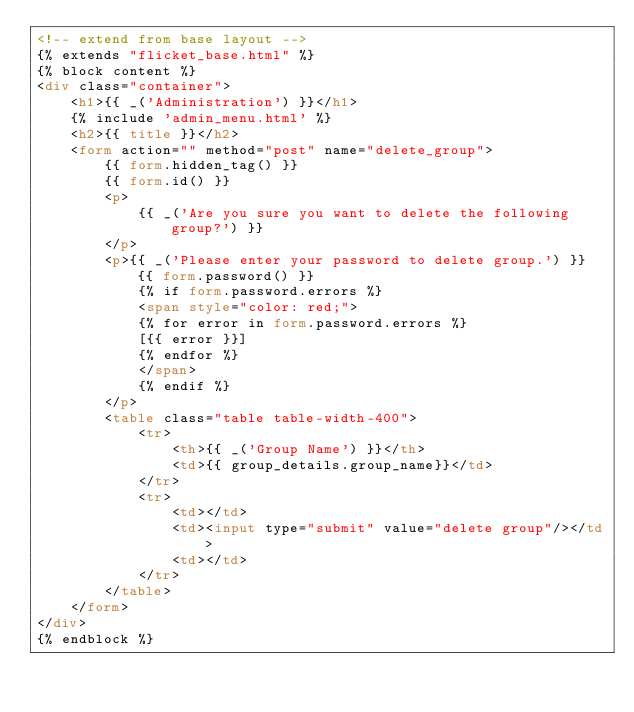<code> <loc_0><loc_0><loc_500><loc_500><_HTML_><!-- extend from base layout -->
{% extends "flicket_base.html" %}
{% block content %}
<div class="container">
    <h1>{{ _('Administration') }}</h1>
    {% include 'admin_menu.html' %}
    <h2>{{ title }}</h2>
    <form action="" method="post" name="delete_group">
        {{ form.hidden_tag() }}
        {{ form.id() }}
        <p>
            {{ _('Are you sure you want to delete the following group?') }}
        </p>
        <p>{{ _('Please enter your password to delete group.') }} {{ form.password() }}
            {% if form.password.errors %}
            <span style="color: red;">
            {% for error in form.password.errors %}
            [{{ error }}]
            {% endfor %}
            </span>
            {% endif %}
        </p>
        <table class="table table-width-400">
            <tr>
                <th>{{ _('Group Name') }}</th>
                <td>{{ group_details.group_name}}</td>
            </tr>
            <tr>
                <td></td>
                <td><input type="submit" value="delete group"/></td>
                <td></td>
            </tr>
        </table>
    </form>
</div>
{% endblock %}</code> 